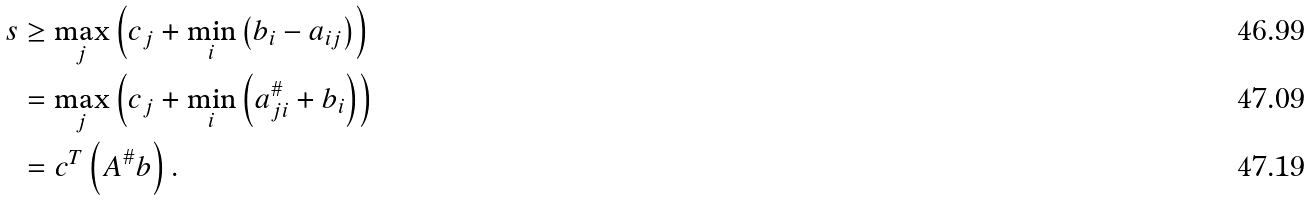<formula> <loc_0><loc_0><loc_500><loc_500>s & \geq \max _ { j } \left ( c _ { j } + \min _ { i } \left ( b _ { i } - a _ { i j } \right ) \right ) \\ & = \max _ { j } \left ( c _ { j } + \min _ { i } \left ( a _ { j i } ^ { \# } + b _ { i } \right ) \right ) \\ & = c ^ { T } \left ( A ^ { \# } b \right ) .</formula> 